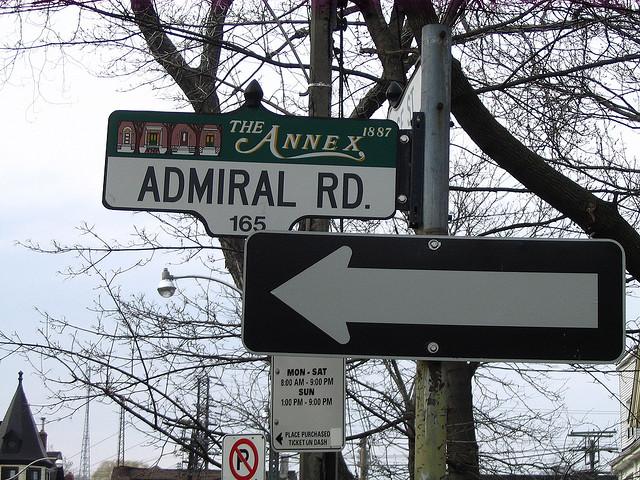Are there leaves on the trees?
Write a very short answer. No. What road is on the street sign?
Keep it brief. Admiral. How many no parking signs are visible?
Answer briefly. 1. 